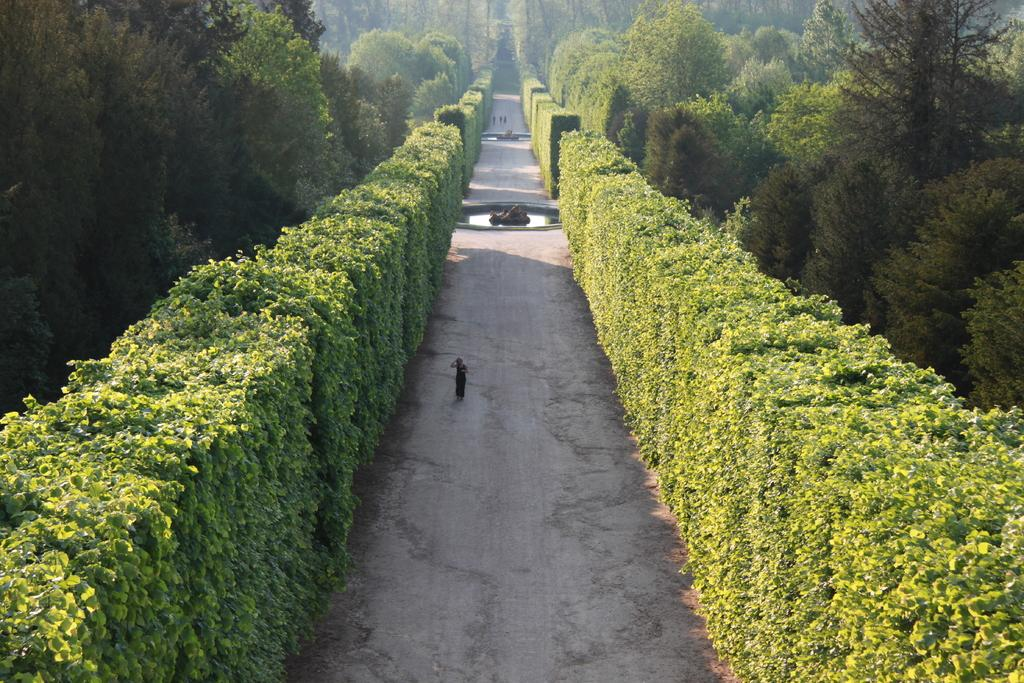What type of vegetation can be seen in the image? There are bushes and trees in the image. What natural element is visible in the image? There is water visible in the image. What can be seen on the road in the image? There are persons on the road in the image. What mathematical operation is being performed by the persons on the road in the image? There is no indication in the image that the persons on the road are performing any mathematical operation. What type of stream is visible in the image? There is no stream visible in the image; only water is present. 